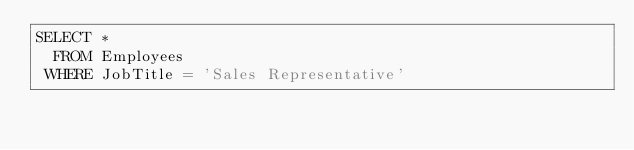<code> <loc_0><loc_0><loc_500><loc_500><_SQL_>SELECT *
  FROM Employees
 WHERE JobTitle = 'Sales Representative'</code> 